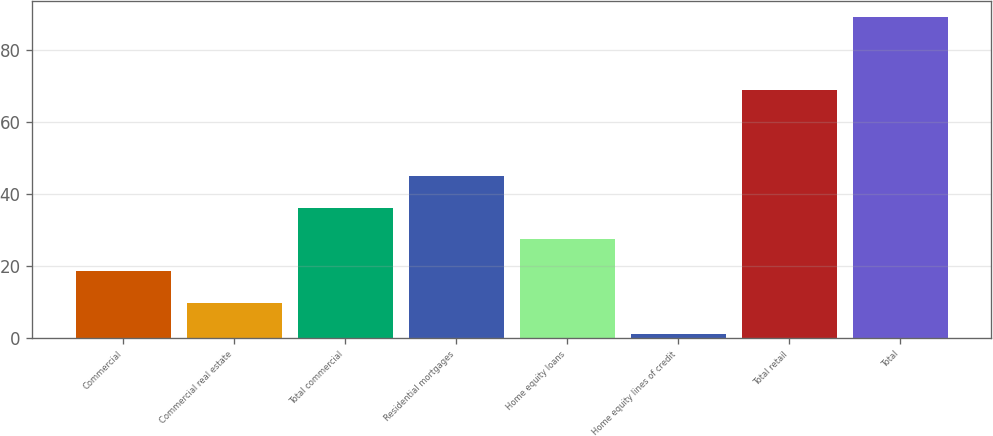Convert chart to OTSL. <chart><loc_0><loc_0><loc_500><loc_500><bar_chart><fcel>Commercial<fcel>Commercial real estate<fcel>Total commercial<fcel>Residential mortgages<fcel>Home equity loans<fcel>Home equity lines of credit<fcel>Total retail<fcel>Total<nl><fcel>18.6<fcel>9.8<fcel>36.2<fcel>45<fcel>27.4<fcel>1<fcel>69<fcel>89<nl></chart> 